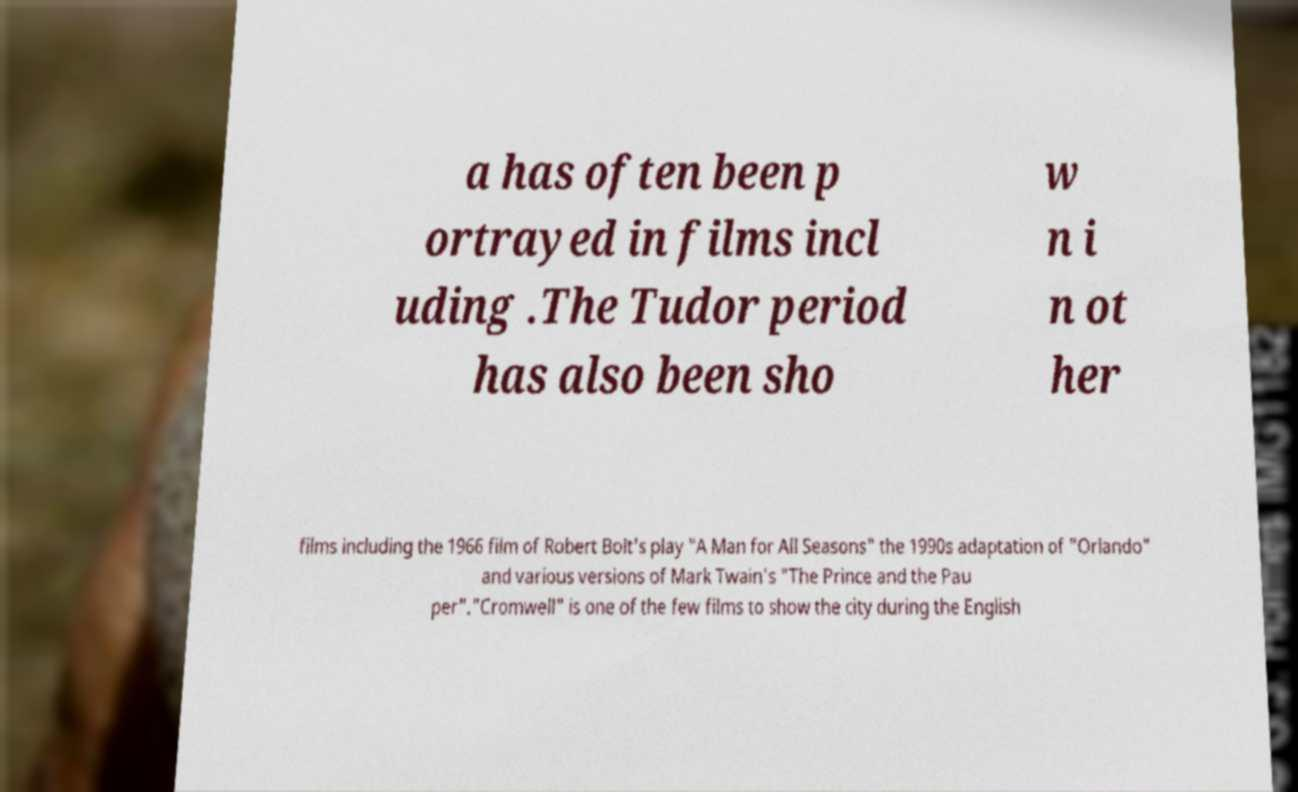Can you accurately transcribe the text from the provided image for me? a has often been p ortrayed in films incl uding .The Tudor period has also been sho w n i n ot her films including the 1966 film of Robert Bolt's play "A Man for All Seasons" the 1990s adaptation of "Orlando" and various versions of Mark Twain's "The Prince and the Pau per"."Cromwell" is one of the few films to show the city during the English 